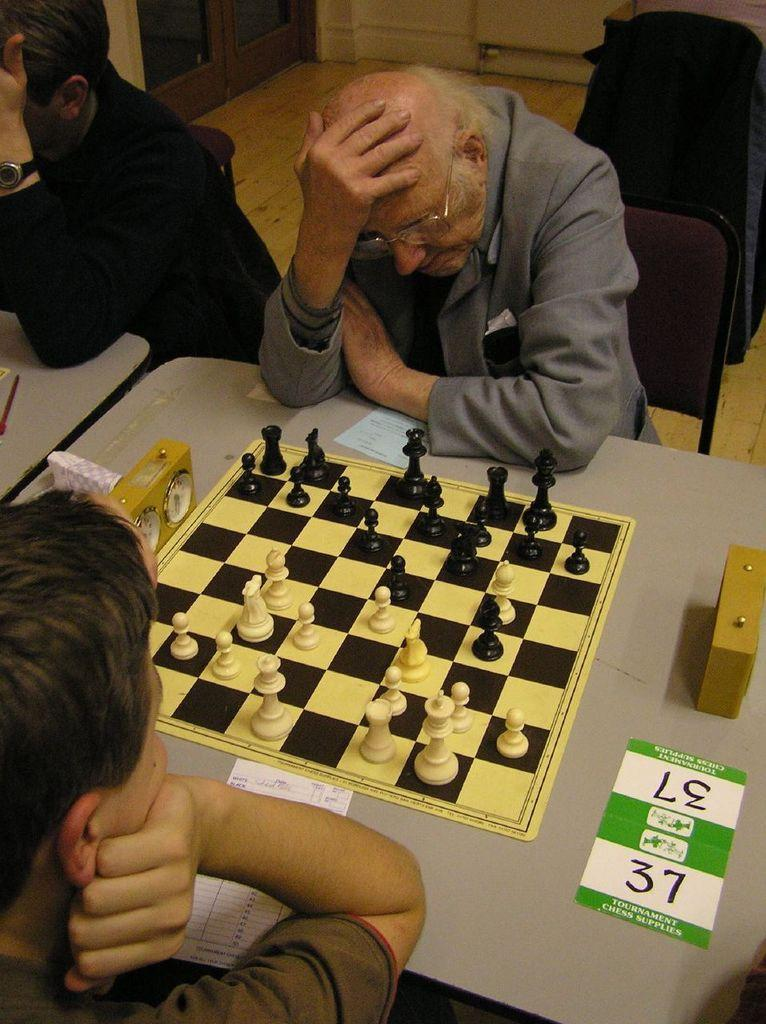How many people are in the image? There are two men in the image. What are the men doing in the image? The men are sitting on a chair and playing chess on a table. What can be seen in the background of the image? There is a wooden wall in the background of the image. What type of beef can be seen hanging from the wooden wall in the image? There is no beef present in the image; it only features two men playing chess and a wooden wall in the background. 